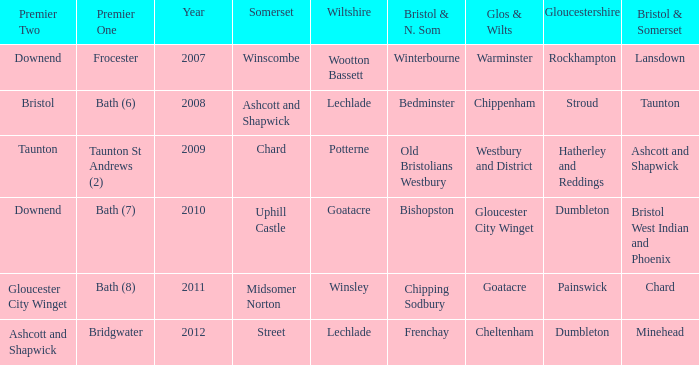What is the latest year where glos & wilts is warminster? 2007.0. 